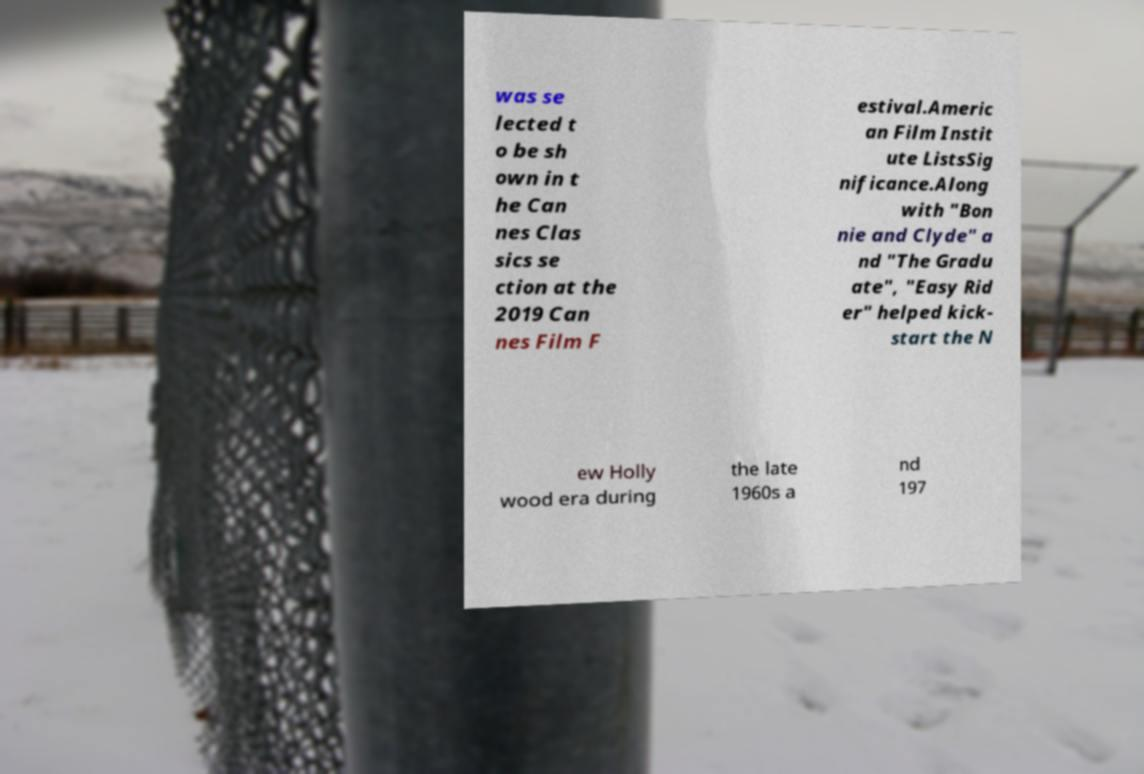I need the written content from this picture converted into text. Can you do that? was se lected t o be sh own in t he Can nes Clas sics se ction at the 2019 Can nes Film F estival.Americ an Film Instit ute ListsSig nificance.Along with "Bon nie and Clyde" a nd "The Gradu ate", "Easy Rid er" helped kick- start the N ew Holly wood era during the late 1960s a nd 197 